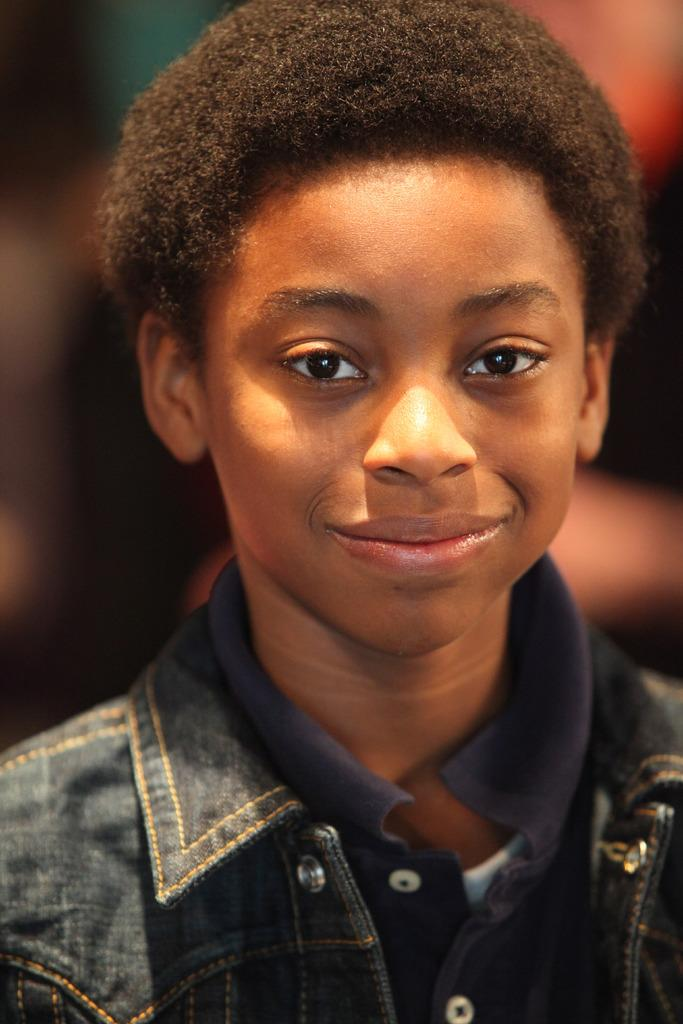What is the main subject of the image? The main subject of the image is a kid. What is the kid wearing in the image? The kid is wearing a black jacket. What expression does the kid have in the image? The kid is smiling. What type of cake is the kid holding in the image? There is no cake present in the image; the kid is not holding anything. Can you see any veins on the kid's hands in the image? The image does not provide enough detail to see individual veins on the kid's hands. Is there a railway visible in the image? There is no railway present in the image. 